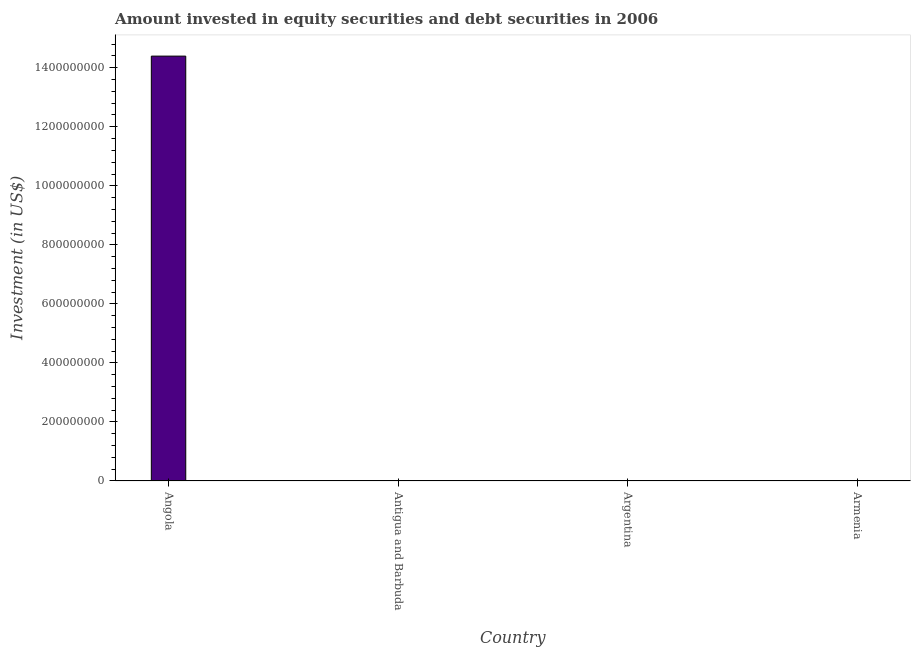Does the graph contain any zero values?
Offer a very short reply. Yes. What is the title of the graph?
Keep it short and to the point. Amount invested in equity securities and debt securities in 2006. What is the label or title of the X-axis?
Make the answer very short. Country. What is the label or title of the Y-axis?
Keep it short and to the point. Investment (in US$). Across all countries, what is the maximum portfolio investment?
Give a very brief answer. 1.44e+09. Across all countries, what is the minimum portfolio investment?
Keep it short and to the point. 0. In which country was the portfolio investment maximum?
Ensure brevity in your answer.  Angola. What is the sum of the portfolio investment?
Make the answer very short. 1.44e+09. What is the average portfolio investment per country?
Make the answer very short. 3.60e+08. What is the median portfolio investment?
Offer a very short reply. 0. What is the difference between the highest and the lowest portfolio investment?
Offer a very short reply. 1.44e+09. What is the Investment (in US$) in Angola?
Your answer should be compact. 1.44e+09. What is the Investment (in US$) of Antigua and Barbuda?
Offer a very short reply. 0. 